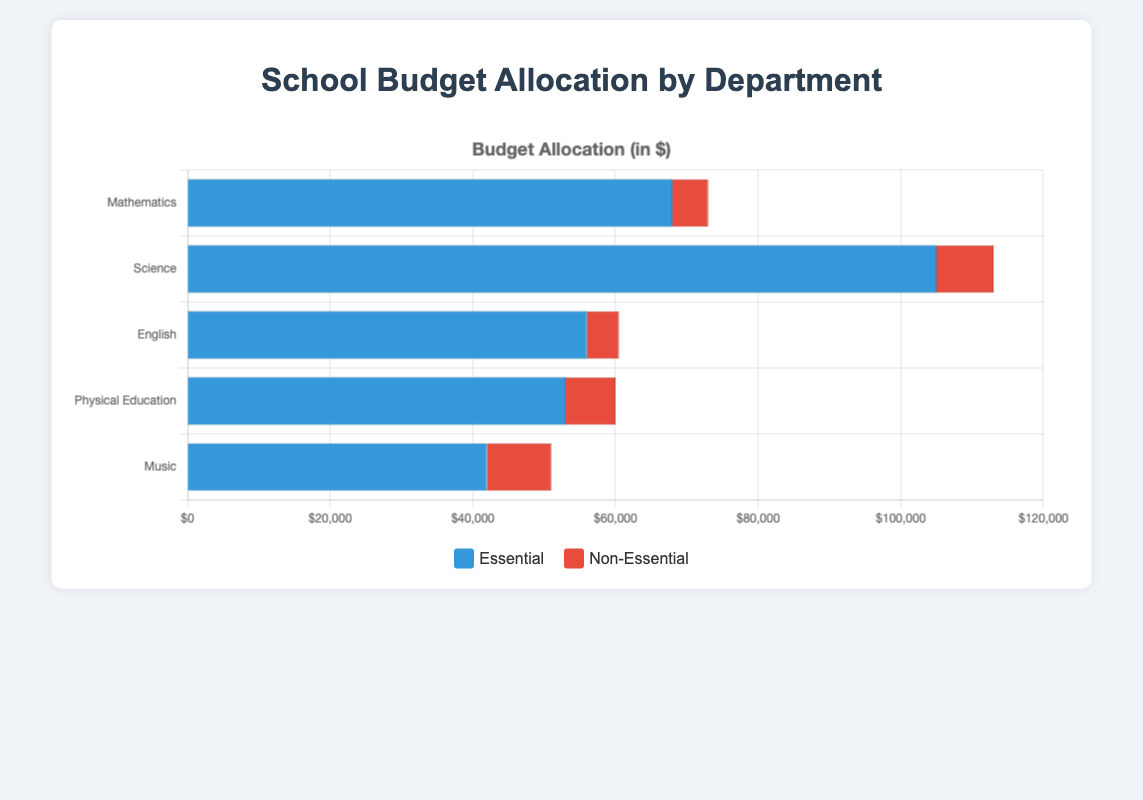Which department has the highest total budget allocation? To find the department with the highest total budget allocation, sum the essential and non-essential expenses for each department. The highest sum will indicate the department with the highest allocation. Here's a breakdown of the totals: Mathematics ($60,000 essential + $5,000 non-essential = $65,000), Science ($105,000 essential + $8,000 non-essential = $113,000), English ($56,000 essential + $4,500 non-essential = $60,500), Physical Education ($53,000 essential + $7,000 non-essential = $60,000), Music ($42,000 essential + $9,000 non-essential = $51,000). Science has the highest total allocation.
Answer: Science How much more is allocated to essential expenses in the Science department compared to the Mathematics department? Sum the essential expenses for both the Science and Mathematics departments and find the difference. Essential expenses: Science ($60,000 + $10,000 + $30,000 + $5,000 = $105,000) and Mathematics ($40,000 + $15,000 + $8,000 + $5,000 = $68,000). The difference is $105,000 - $68,000 = $37,000.
Answer: $37,000 Which department has the smallest allocation for non-essential expenses? Compare the total non-essential expenses for each department. Mathematics ($5,000), Science ($8,000), English ($4,500), Physical Education ($7,000), and Music ($9,000). The English department has the smallest non-essential allocation, $4,500.
Answer: English What is the total budget allocation for the Physical Education department? Add the essential and non-essential expenses for the Physical Education department. Essential: $30,000 (Sports Equipment) + $10,000 (Uniforms) + $5,000 (Safety Gear) + $8,000 (Facility Maintenance) = $53,000. Non-essential: $4,000 (Special Events) + $3,000 (Guest Coaches) = $7,000. Total: $53,000 essential + $7,000 non-essential = $60,000.
Answer: $60,000 Which department dedicates a higher proportion of their budget to non-essential expenses, English or Music? Calculate the proportion of non-essential expenses for both departments. English: Essential total = $56,000, Non-essential total = $4,500. Proportion = $4,500 / ($60,500) ≈ 0.074. Music: Essential total = $42,000, Non-essential total = $9,000. Proportion = $9,000 / ($51,000) ≈ 0.176. Music has a higher proportion dedicated to non-essential expenses.
Answer: Music Is there any department where the non-essential expenses exceed 20% of the total budget? Calculate the proportion of non-essential expenses for each department:
Mathematics = $5,000 / $65,000 ≈ 0.077;
Science = $8,000 / $113,000 ≈ 0.071;
English = $4,500 / $60,500 ≈ 0.074;
Physical Education = $7,000 / $60,000 ≈ 0.117;
Music = $9,000 / $51,000 ≈ 0.176.
None of the departments exceed 20% for non-essential expenses.
Answer: No 